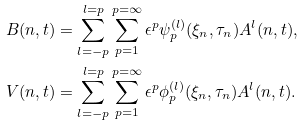<formula> <loc_0><loc_0><loc_500><loc_500>& B ( n , t ) = \sum ^ { l = p } _ { l = - p } \sum ^ { p = \infty } _ { p = 1 } \epsilon ^ { p } \psi ^ { ( l ) } _ { p } ( \xi _ { n } , \tau _ { n } ) A ^ { l } ( n , t ) , \\ & V ( n , t ) = \sum ^ { l = p } _ { l = - p } \sum ^ { p = \infty } _ { p = 1 } \epsilon ^ { p } \phi ^ { ( l ) } _ { p } ( \xi _ { n } , \tau _ { n } ) A ^ { l } ( n , t ) .</formula> 